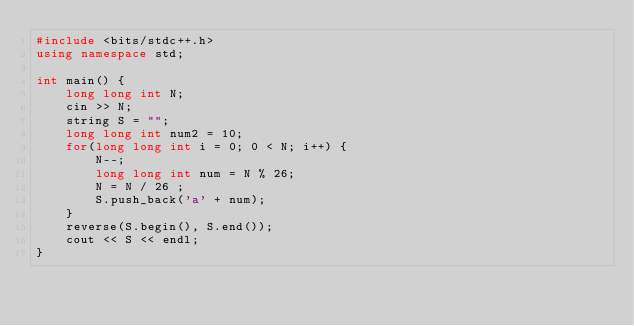Convert code to text. <code><loc_0><loc_0><loc_500><loc_500><_C++_>#include <bits/stdc++.h>
using namespace std;

int main() {
    long long int N;
    cin >> N;
    string S = "";
    long long int num2 = 10;
    for(long long int i = 0; 0 < N; i++) {
        N--;
        long long int num = N % 26;
        N = N / 26 ;
        S.push_back('a' + num);
    }
    reverse(S.begin(), S.end());
    cout << S << endl;
}</code> 